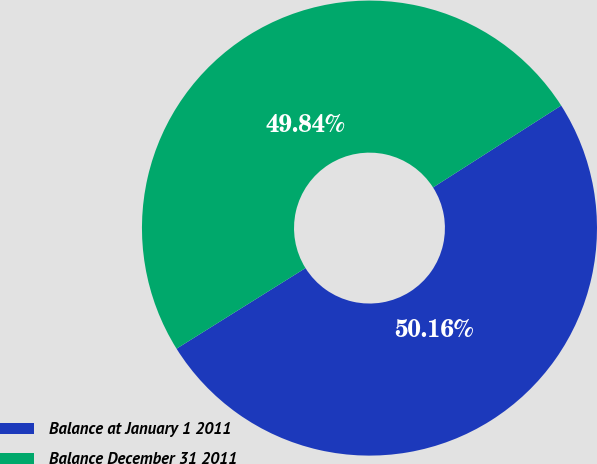<chart> <loc_0><loc_0><loc_500><loc_500><pie_chart><fcel>Balance at January 1 2011<fcel>Balance December 31 2011<nl><fcel>50.16%<fcel>49.84%<nl></chart> 